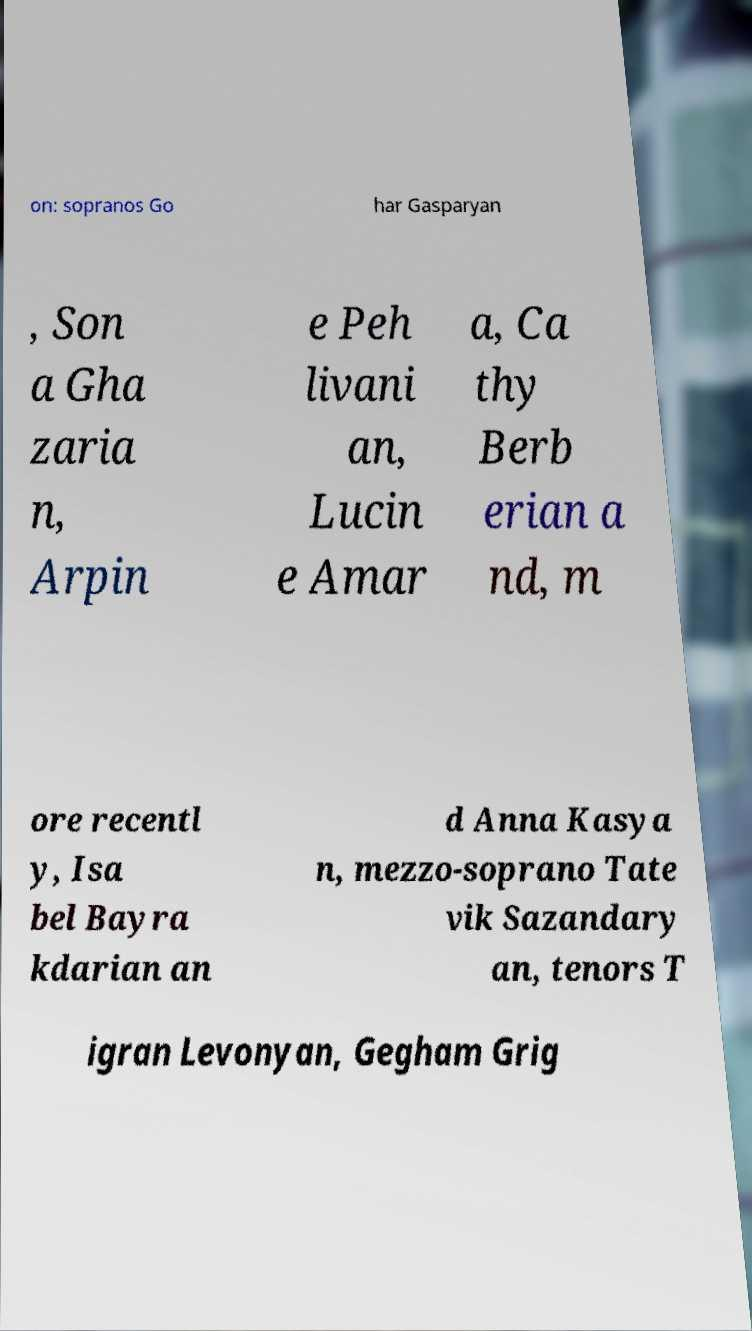Could you assist in decoding the text presented in this image and type it out clearly? on: sopranos Go har Gasparyan , Son a Gha zaria n, Arpin e Peh livani an, Lucin e Amar a, Ca thy Berb erian a nd, m ore recentl y, Isa bel Bayra kdarian an d Anna Kasya n, mezzo-soprano Tate vik Sazandary an, tenors T igran Levonyan, Gegham Grig 